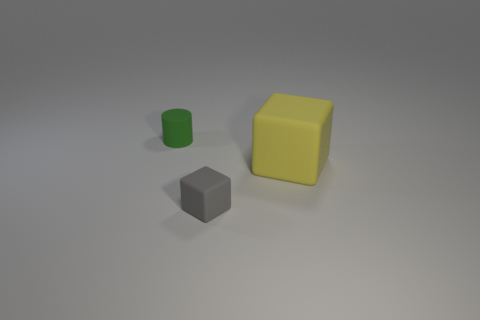Add 3 large yellow objects. How many objects exist? 6 Subtract all cubes. How many objects are left? 1 Add 1 small cylinders. How many small cylinders exist? 2 Subtract 1 gray blocks. How many objects are left? 2 Subtract all small matte cubes. Subtract all small objects. How many objects are left? 0 Add 2 small gray objects. How many small gray objects are left? 3 